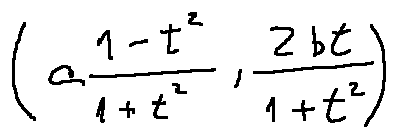<formula> <loc_0><loc_0><loc_500><loc_500>( a \frac { 1 - t ^ { 2 } } { 1 + t ^ { 2 } } , \frac { 2 b t } { 1 + t ^ { 2 } } )</formula> 